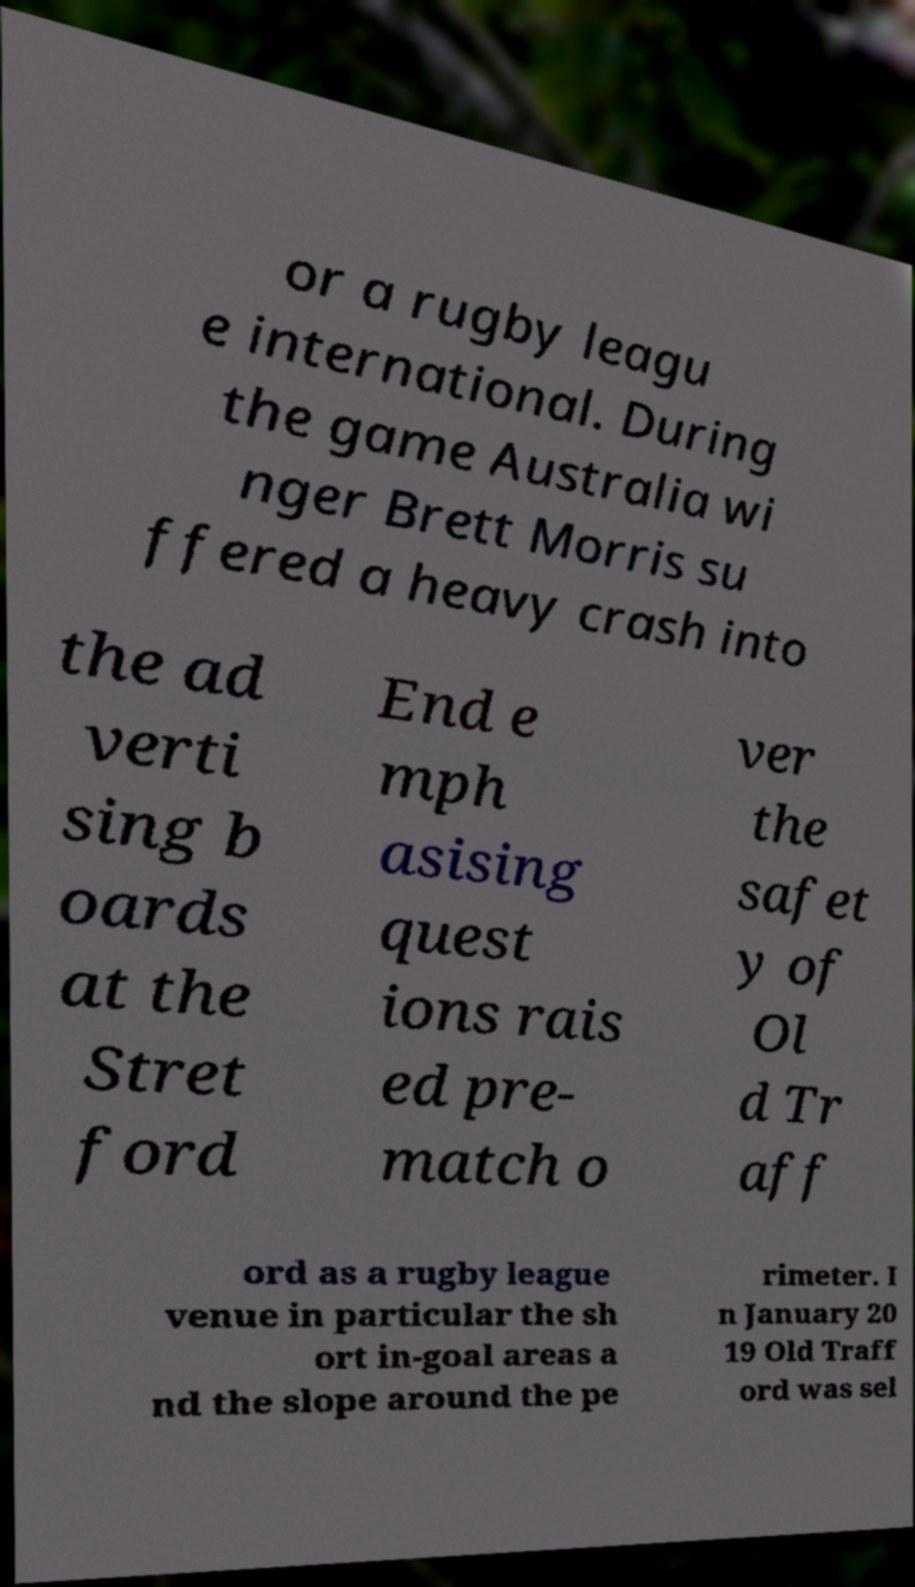Please read and relay the text visible in this image. What does it say? or a rugby leagu e international. During the game Australia wi nger Brett Morris su ffered a heavy crash into the ad verti sing b oards at the Stret ford End e mph asising quest ions rais ed pre- match o ver the safet y of Ol d Tr aff ord as a rugby league venue in particular the sh ort in-goal areas a nd the slope around the pe rimeter. I n January 20 19 Old Traff ord was sel 